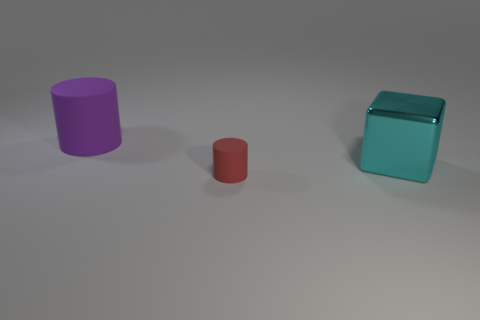Add 1 cylinders. How many objects exist? 4 Subtract all cylinders. How many objects are left? 1 Subtract all tiny matte spheres. Subtract all big rubber things. How many objects are left? 2 Add 2 big cyan cubes. How many big cyan cubes are left? 3 Add 2 purple balls. How many purple balls exist? 2 Subtract 0 brown cylinders. How many objects are left? 3 